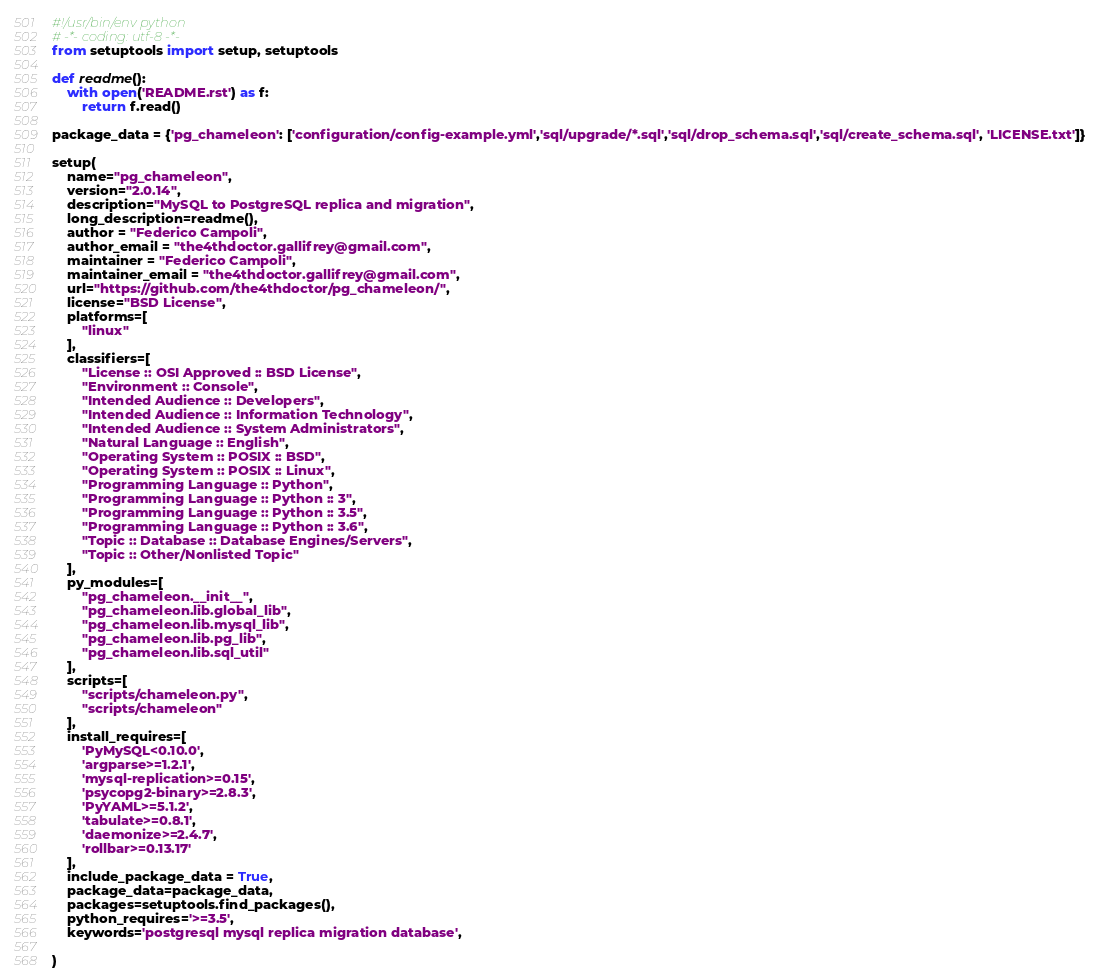<code> <loc_0><loc_0><loc_500><loc_500><_Python_>#!/usr/bin/env python
# -*- coding: utf-8 -*-
from setuptools import setup, setuptools

def readme():
    with open('README.rst') as f:
        return f.read()

package_data = {'pg_chameleon': ['configuration/config-example.yml','sql/upgrade/*.sql','sql/drop_schema.sql','sql/create_schema.sql', 'LICENSE.txt']}

setup(
    name="pg_chameleon",
    version="2.0.14",
    description="MySQL to PostgreSQL replica and migration",
    long_description=readme(),
    author = "Federico Campoli",
    author_email = "the4thdoctor.gallifrey@gmail.com",
    maintainer = "Federico Campoli", 
    maintainer_email = "the4thdoctor.gallifrey@gmail.com",
    url="https://github.com/the4thdoctor/pg_chameleon/",
    license="BSD License",
    platforms=[
        "linux"
    ],
    classifiers=[
        "License :: OSI Approved :: BSD License",
        "Environment :: Console",
        "Intended Audience :: Developers",
        "Intended Audience :: Information Technology",
        "Intended Audience :: System Administrators",
        "Natural Language :: English",
        "Operating System :: POSIX :: BSD",
        "Operating System :: POSIX :: Linux",
        "Programming Language :: Python",
        "Programming Language :: Python :: 3",
        "Programming Language :: Python :: 3.5",
        "Programming Language :: Python :: 3.6",
        "Topic :: Database :: Database Engines/Servers",
        "Topic :: Other/Nonlisted Topic"
    ],
    py_modules=[
        "pg_chameleon.__init__",
        "pg_chameleon.lib.global_lib",
        "pg_chameleon.lib.mysql_lib",
        "pg_chameleon.lib.pg_lib",
        "pg_chameleon.lib.sql_util"
    ],
    scripts=[
        "scripts/chameleon.py", 
        "scripts/chameleon"
    ],
    install_requires=[
        'PyMySQL<0.10.0', 
        'argparse>=1.2.1', 
        'mysql-replication>=0.15', 
        'psycopg2-binary>=2.8.3', 
        'PyYAML>=5.1.2', 
        'tabulate>=0.8.1', 
        'daemonize>=2.4.7', 
        'rollbar>=0.13.17'
    ],
    include_package_data = True, 
    package_data=package_data,
    packages=setuptools.find_packages(),
    python_requires='>=3.5',
    keywords='postgresql mysql replica migration database',
    
)
</code> 